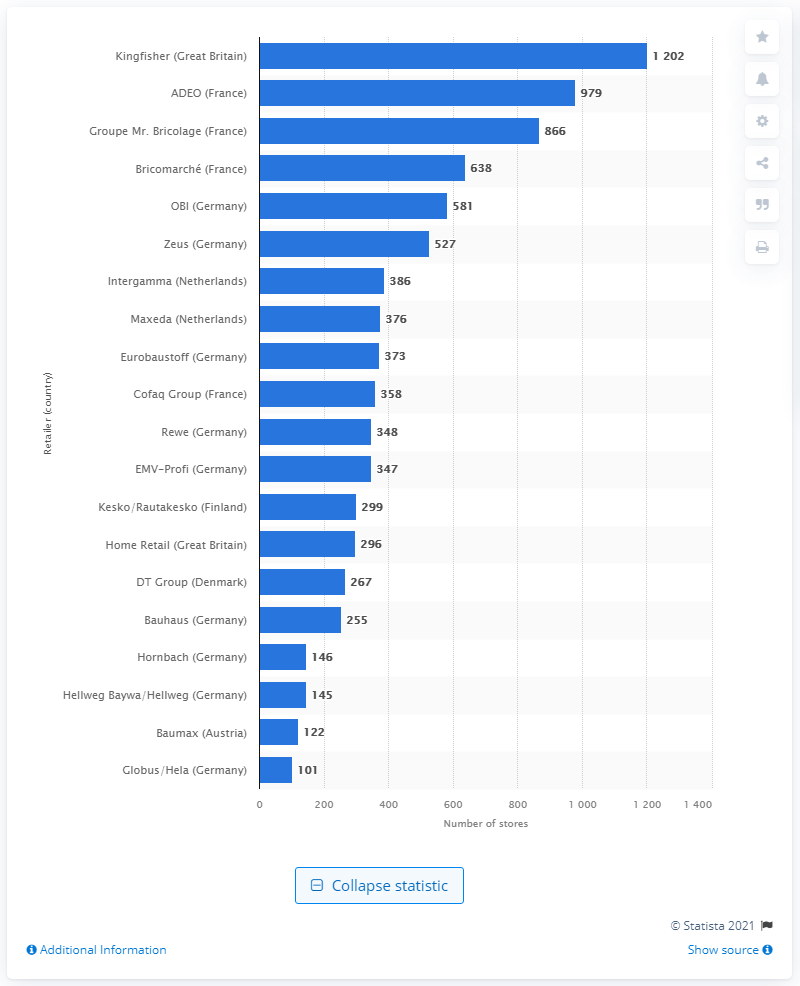How does the retail landscape for home improvement in Great Britain compare to France based on this data? From the data depicted, Great Britain's retail landscape in the home improvement sector was dominated by Kingfisher with 1,202 stores, whereas France had a more distributed landscape between ADEO with 979 stores and Groupe Mr. Bricolage with 866, followed by Bricomarché. This signifies that Kingfisher had a more commanding presence in Great Britain, while France had a more competitive environment with multiple large retailers. 